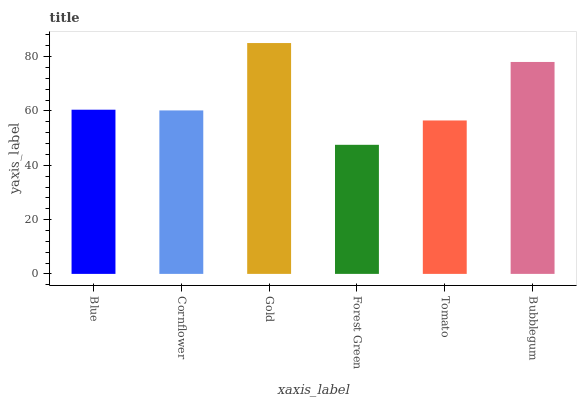Is Forest Green the minimum?
Answer yes or no. Yes. Is Gold the maximum?
Answer yes or no. Yes. Is Cornflower the minimum?
Answer yes or no. No. Is Cornflower the maximum?
Answer yes or no. No. Is Blue greater than Cornflower?
Answer yes or no. Yes. Is Cornflower less than Blue?
Answer yes or no. Yes. Is Cornflower greater than Blue?
Answer yes or no. No. Is Blue less than Cornflower?
Answer yes or no. No. Is Blue the high median?
Answer yes or no. Yes. Is Cornflower the low median?
Answer yes or no. Yes. Is Bubblegum the high median?
Answer yes or no. No. Is Forest Green the low median?
Answer yes or no. No. 